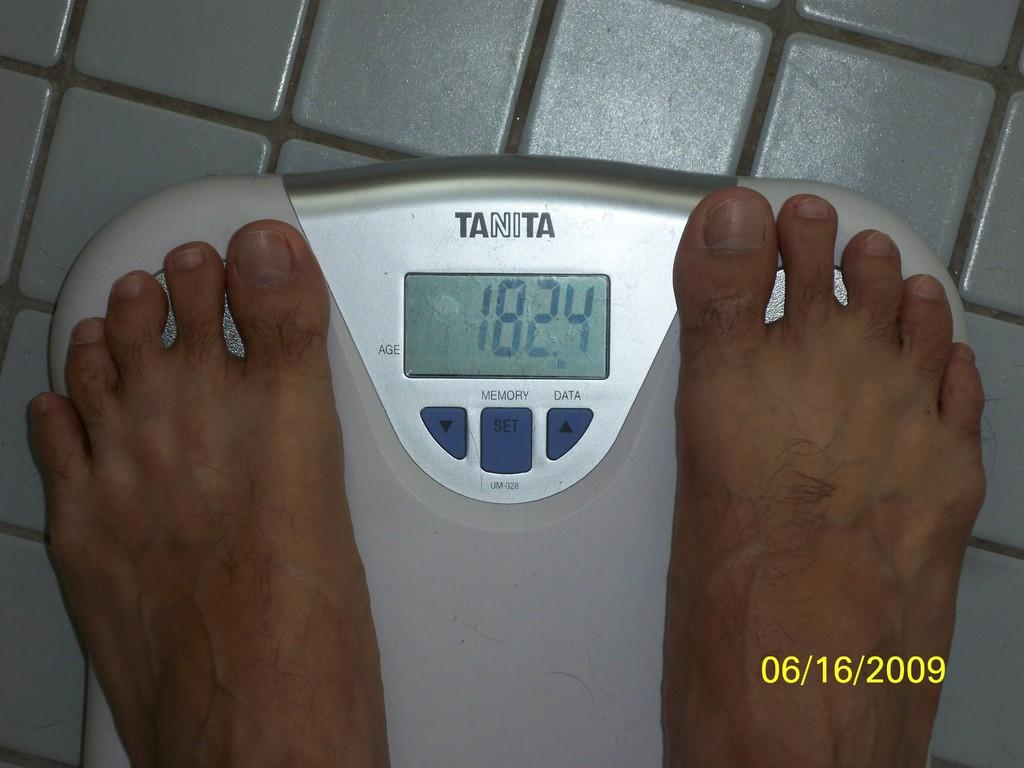<image>
Present a compact description of the photo's key features. A persons feet are on s Tanita scale, showing 182.4 pounds 